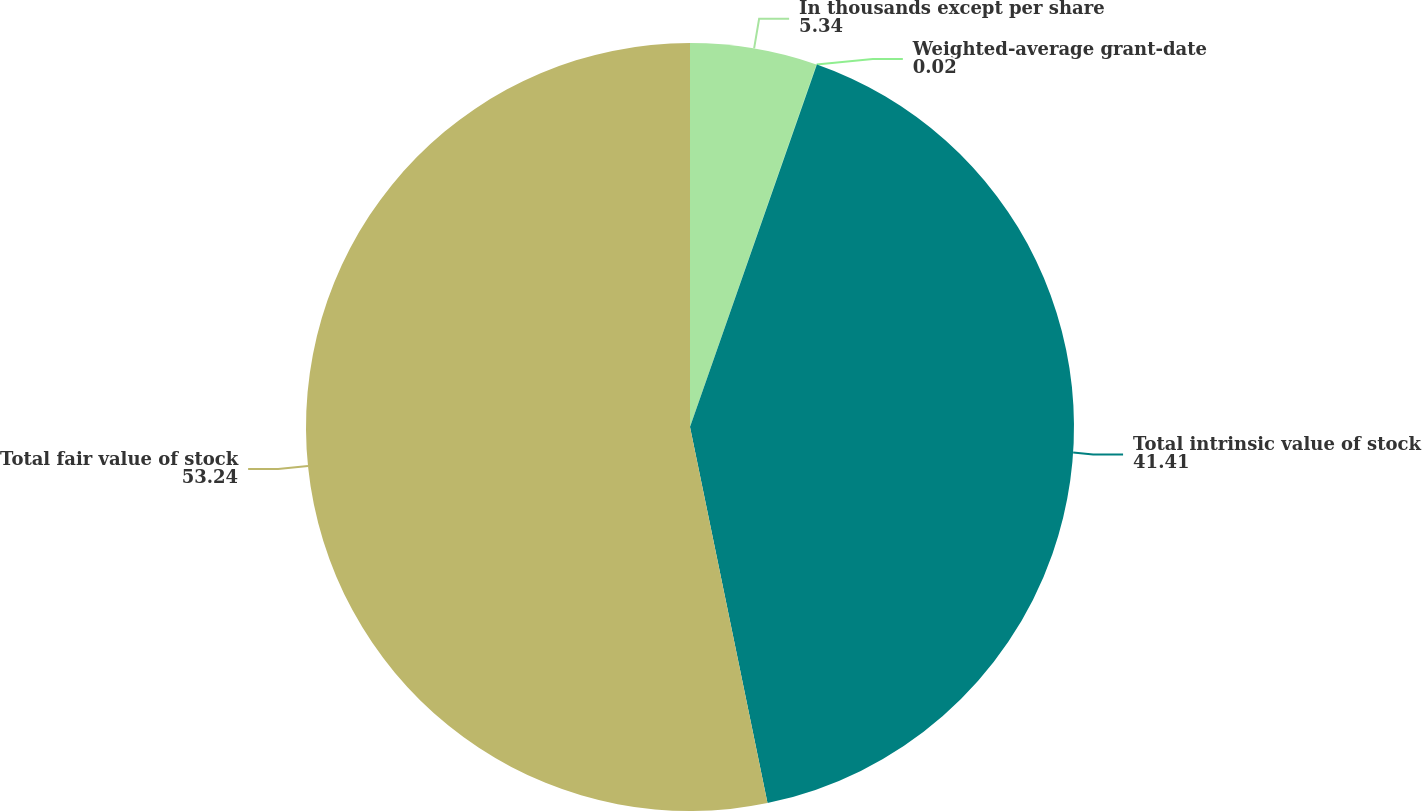<chart> <loc_0><loc_0><loc_500><loc_500><pie_chart><fcel>In thousands except per share<fcel>Weighted-average grant-date<fcel>Total intrinsic value of stock<fcel>Total fair value of stock<nl><fcel>5.34%<fcel>0.02%<fcel>41.41%<fcel>53.24%<nl></chart> 